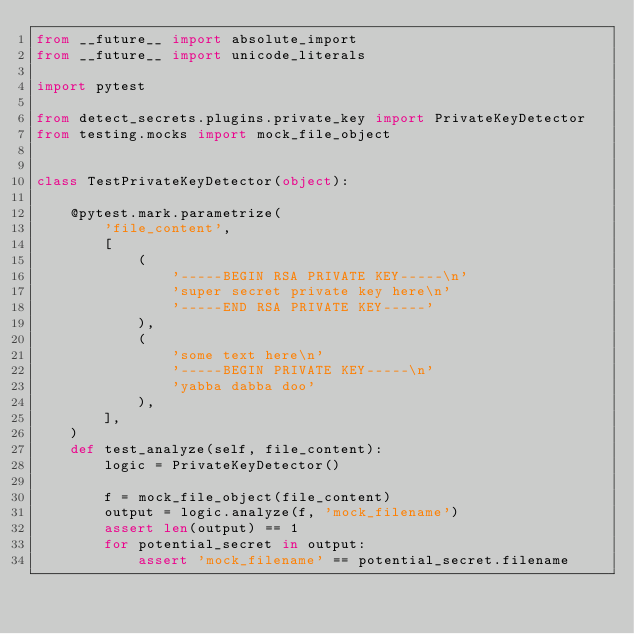<code> <loc_0><loc_0><loc_500><loc_500><_Python_>from __future__ import absolute_import
from __future__ import unicode_literals

import pytest

from detect_secrets.plugins.private_key import PrivateKeyDetector
from testing.mocks import mock_file_object


class TestPrivateKeyDetector(object):

    @pytest.mark.parametrize(
        'file_content',
        [
            (
                '-----BEGIN RSA PRIVATE KEY-----\n'
                'super secret private key here\n'
                '-----END RSA PRIVATE KEY-----'
            ),
            (
                'some text here\n'
                '-----BEGIN PRIVATE KEY-----\n'
                'yabba dabba doo'
            ),
        ],
    )
    def test_analyze(self, file_content):
        logic = PrivateKeyDetector()

        f = mock_file_object(file_content)
        output = logic.analyze(f, 'mock_filename')
        assert len(output) == 1
        for potential_secret in output:
            assert 'mock_filename' == potential_secret.filename
</code> 